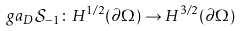Convert formula to latex. <formula><loc_0><loc_0><loc_500><loc_500>\ g a _ { D } { \mathcal { S } _ { - 1 } } \colon H ^ { 1 / 2 } ( \partial \Omega ) \rightarrow H ^ { 3 / 2 } ( \partial \Omega )</formula> 